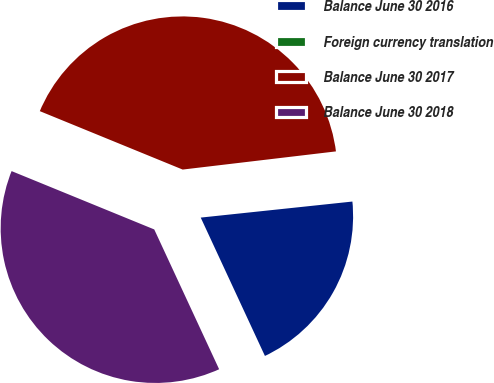<chart> <loc_0><loc_0><loc_500><loc_500><pie_chart><fcel>Balance June 30 2016<fcel>Foreign currency translation<fcel>Balance June 30 2017<fcel>Balance June 30 2018<nl><fcel>19.76%<fcel>0.2%<fcel>41.94%<fcel>38.09%<nl></chart> 